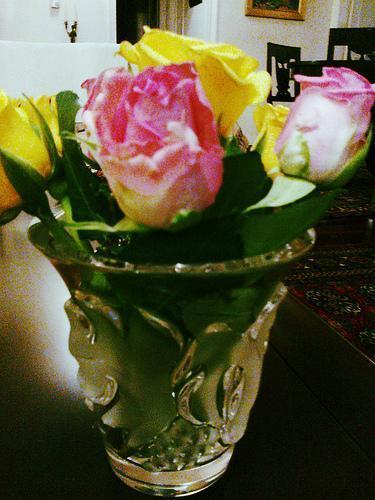How many vases are in the picture?
Give a very brief answer. 1. How many pink flowers are there?
Give a very brief answer. 2. 